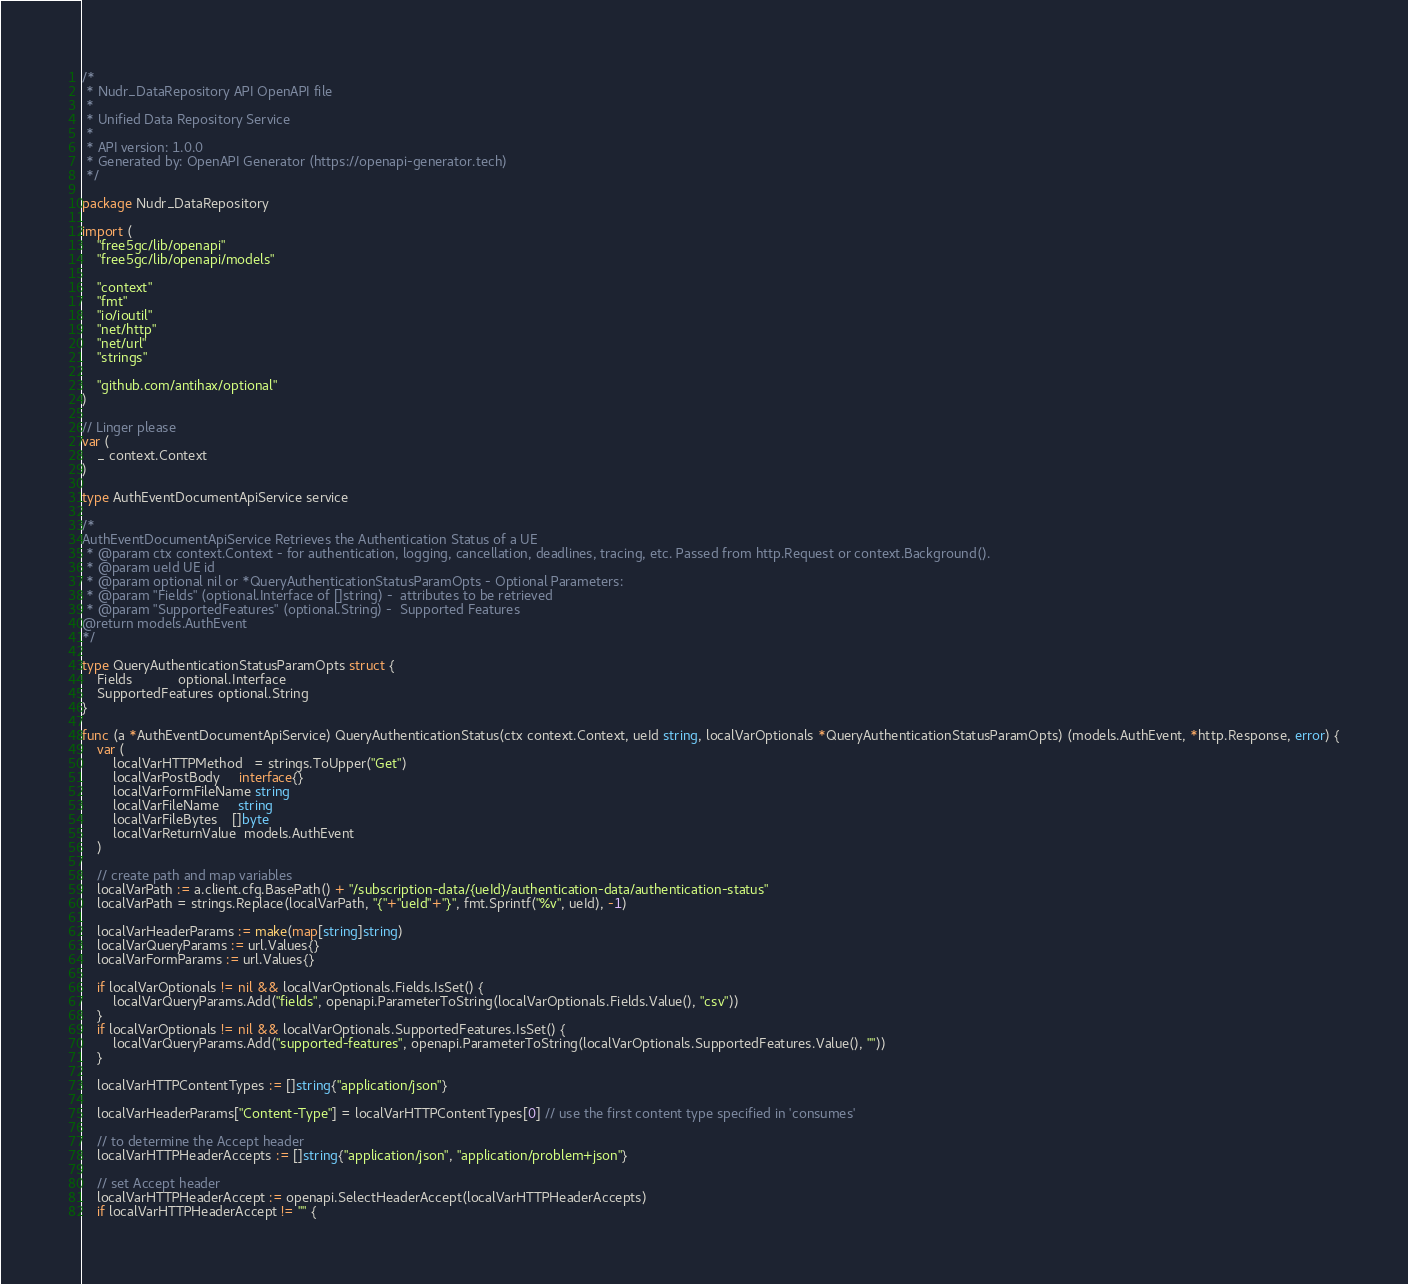<code> <loc_0><loc_0><loc_500><loc_500><_Go_>/*
 * Nudr_DataRepository API OpenAPI file
 *
 * Unified Data Repository Service
 *
 * API version: 1.0.0
 * Generated by: OpenAPI Generator (https://openapi-generator.tech)
 */

package Nudr_DataRepository

import (
	"free5gc/lib/openapi"
	"free5gc/lib/openapi/models"

	"context"
	"fmt"
	"io/ioutil"
	"net/http"
	"net/url"
	"strings"

	"github.com/antihax/optional"
)

// Linger please
var (
	_ context.Context
)

type AuthEventDocumentApiService service

/*
AuthEventDocumentApiService Retrieves the Authentication Status of a UE
 * @param ctx context.Context - for authentication, logging, cancellation, deadlines, tracing, etc. Passed from http.Request or context.Background().
 * @param ueId UE id
 * @param optional nil or *QueryAuthenticationStatusParamOpts - Optional Parameters:
 * @param "Fields" (optional.Interface of []string) -  attributes to be retrieved
 * @param "SupportedFeatures" (optional.String) -  Supported Features
@return models.AuthEvent
*/

type QueryAuthenticationStatusParamOpts struct {
	Fields            optional.Interface
	SupportedFeatures optional.String
}

func (a *AuthEventDocumentApiService) QueryAuthenticationStatus(ctx context.Context, ueId string, localVarOptionals *QueryAuthenticationStatusParamOpts) (models.AuthEvent, *http.Response, error) {
	var (
		localVarHTTPMethod   = strings.ToUpper("Get")
		localVarPostBody     interface{}
		localVarFormFileName string
		localVarFileName     string
		localVarFileBytes    []byte
		localVarReturnValue  models.AuthEvent
	)

	// create path and map variables
	localVarPath := a.client.cfg.BasePath() + "/subscription-data/{ueId}/authentication-data/authentication-status"
	localVarPath = strings.Replace(localVarPath, "{"+"ueId"+"}", fmt.Sprintf("%v", ueId), -1)

	localVarHeaderParams := make(map[string]string)
	localVarQueryParams := url.Values{}
	localVarFormParams := url.Values{}

	if localVarOptionals != nil && localVarOptionals.Fields.IsSet() {
		localVarQueryParams.Add("fields", openapi.ParameterToString(localVarOptionals.Fields.Value(), "csv"))
	}
	if localVarOptionals != nil && localVarOptionals.SupportedFeatures.IsSet() {
		localVarQueryParams.Add("supported-features", openapi.ParameterToString(localVarOptionals.SupportedFeatures.Value(), ""))
	}

	localVarHTTPContentTypes := []string{"application/json"}

	localVarHeaderParams["Content-Type"] = localVarHTTPContentTypes[0] // use the first content type specified in 'consumes'

	// to determine the Accept header
	localVarHTTPHeaderAccepts := []string{"application/json", "application/problem+json"}

	// set Accept header
	localVarHTTPHeaderAccept := openapi.SelectHeaderAccept(localVarHTTPHeaderAccepts)
	if localVarHTTPHeaderAccept != "" {</code> 